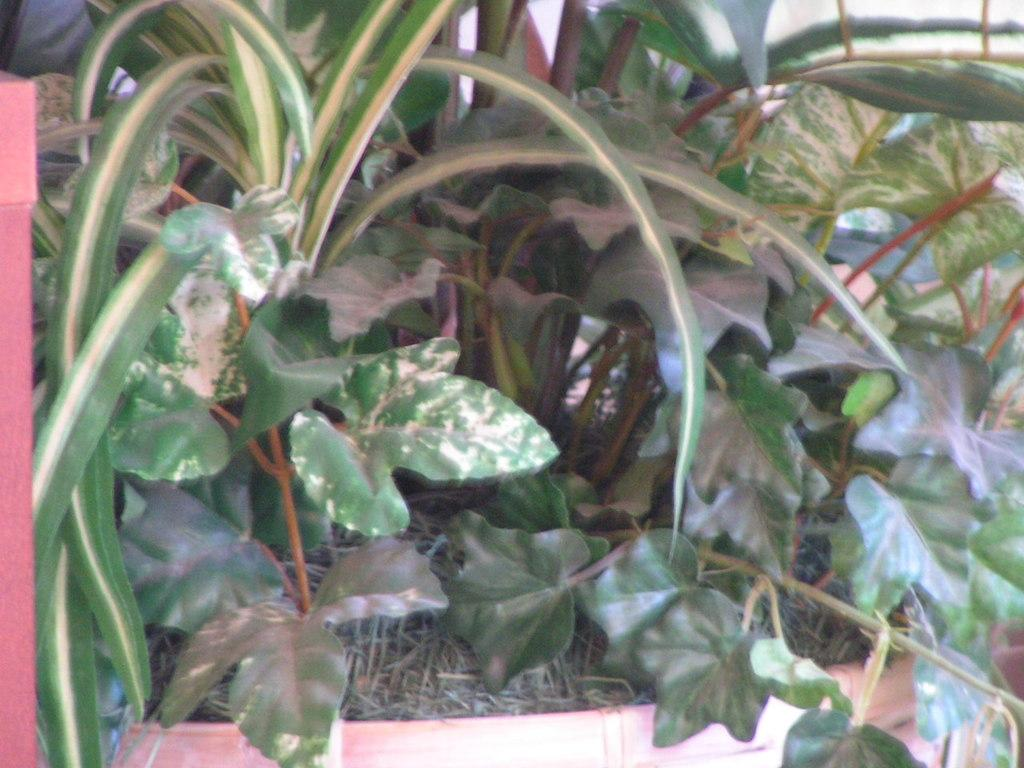What type of living organisms are at the bottom of the image? There are plants at the bottom of the image. What can be seen in the background of the image? There are objects visible in the background of the image. What type of bait is being used to catch fish in the image? There is no indication of fishing or bait in the image; it features plants at the bottom and objects in the background. What type of fuel is being used to power a vehicle in the image? There is no vehicle or fuel present in the image. 